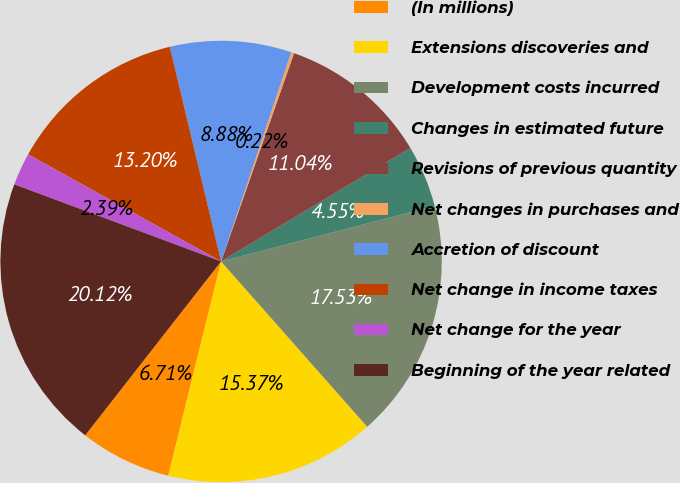Convert chart to OTSL. <chart><loc_0><loc_0><loc_500><loc_500><pie_chart><fcel>(In millions)<fcel>Extensions discoveries and<fcel>Development costs incurred<fcel>Changes in estimated future<fcel>Revisions of previous quantity<fcel>Net changes in purchases and<fcel>Accretion of discount<fcel>Net change in income taxes<fcel>Net change for the year<fcel>Beginning of the year related<nl><fcel>6.71%<fcel>15.37%<fcel>17.53%<fcel>4.55%<fcel>11.04%<fcel>0.22%<fcel>8.88%<fcel>13.2%<fcel>2.39%<fcel>20.12%<nl></chart> 